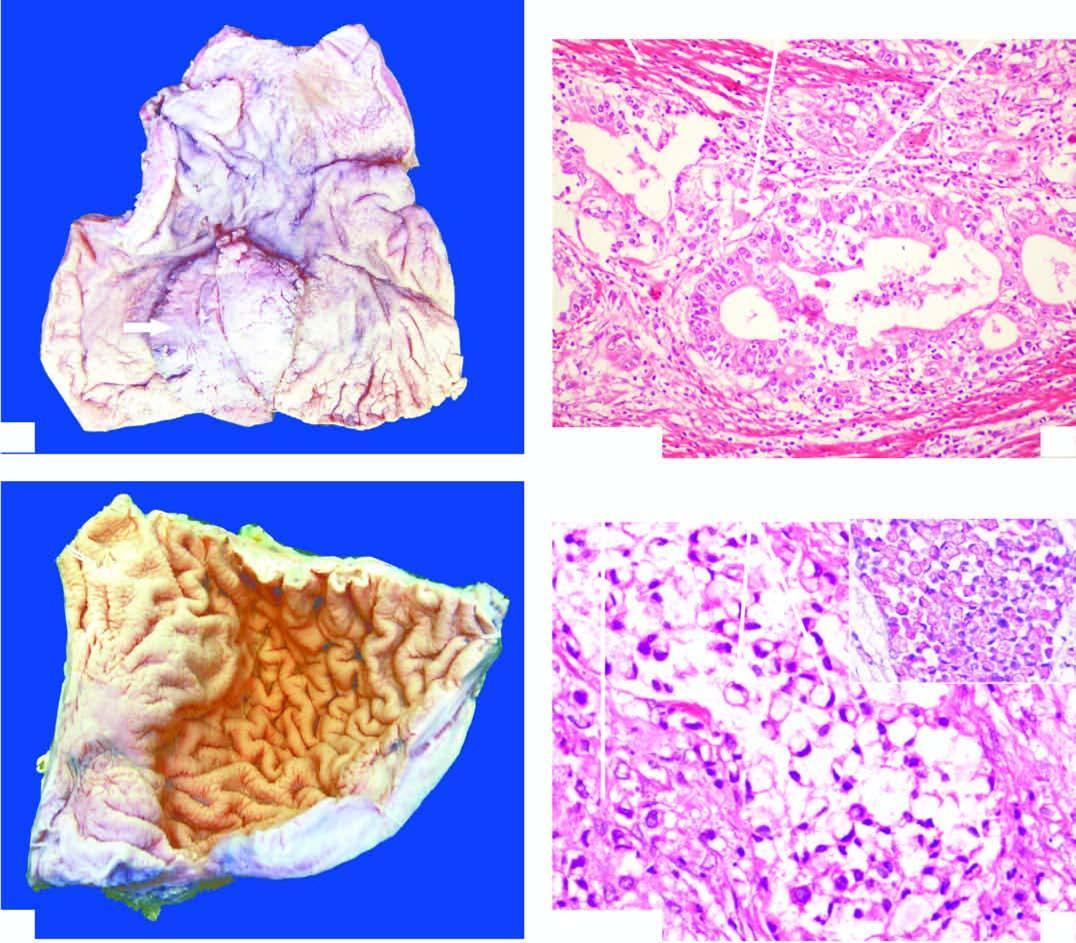s the stroma desmoplastic?
Answer the question using a single word or phrase. Yes 